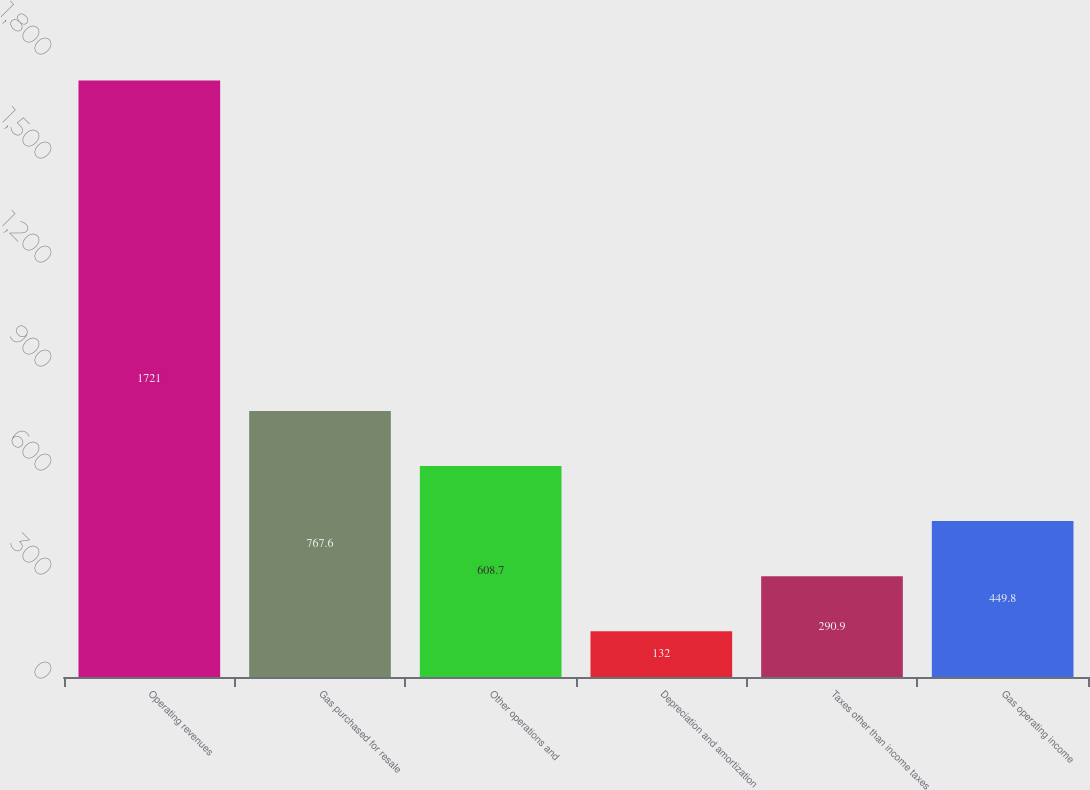<chart> <loc_0><loc_0><loc_500><loc_500><bar_chart><fcel>Operating revenues<fcel>Gas purchased for resale<fcel>Other operations and<fcel>Depreciation and amortization<fcel>Taxes other than income taxes<fcel>Gas operating income<nl><fcel>1721<fcel>767.6<fcel>608.7<fcel>132<fcel>290.9<fcel>449.8<nl></chart> 